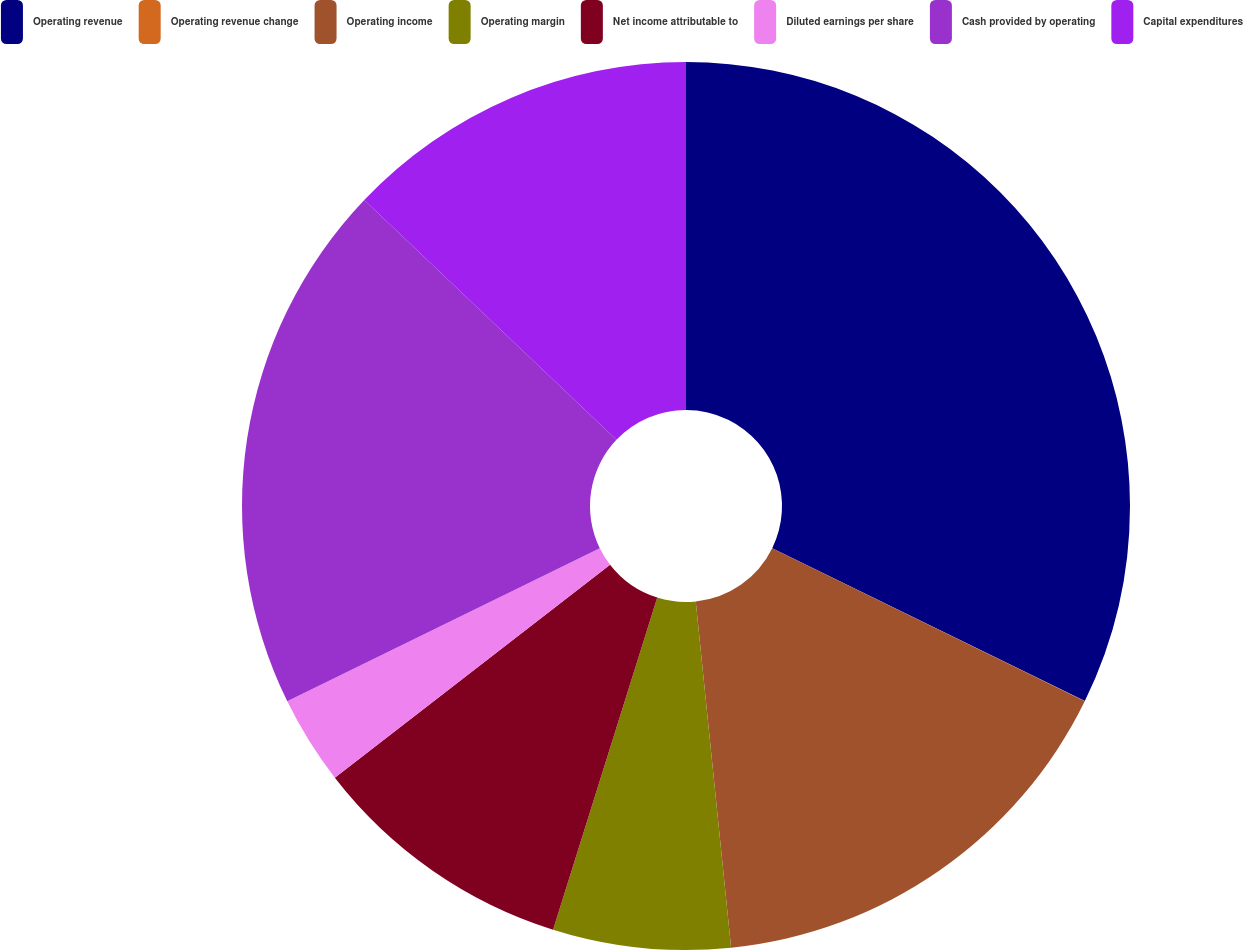Convert chart. <chart><loc_0><loc_0><loc_500><loc_500><pie_chart><fcel>Operating revenue<fcel>Operating revenue change<fcel>Operating income<fcel>Operating margin<fcel>Net income attributable to<fcel>Diluted earnings per share<fcel>Cash provided by operating<fcel>Capital expenditures<nl><fcel>32.24%<fcel>0.01%<fcel>16.13%<fcel>6.46%<fcel>9.68%<fcel>3.23%<fcel>19.35%<fcel>12.9%<nl></chart> 